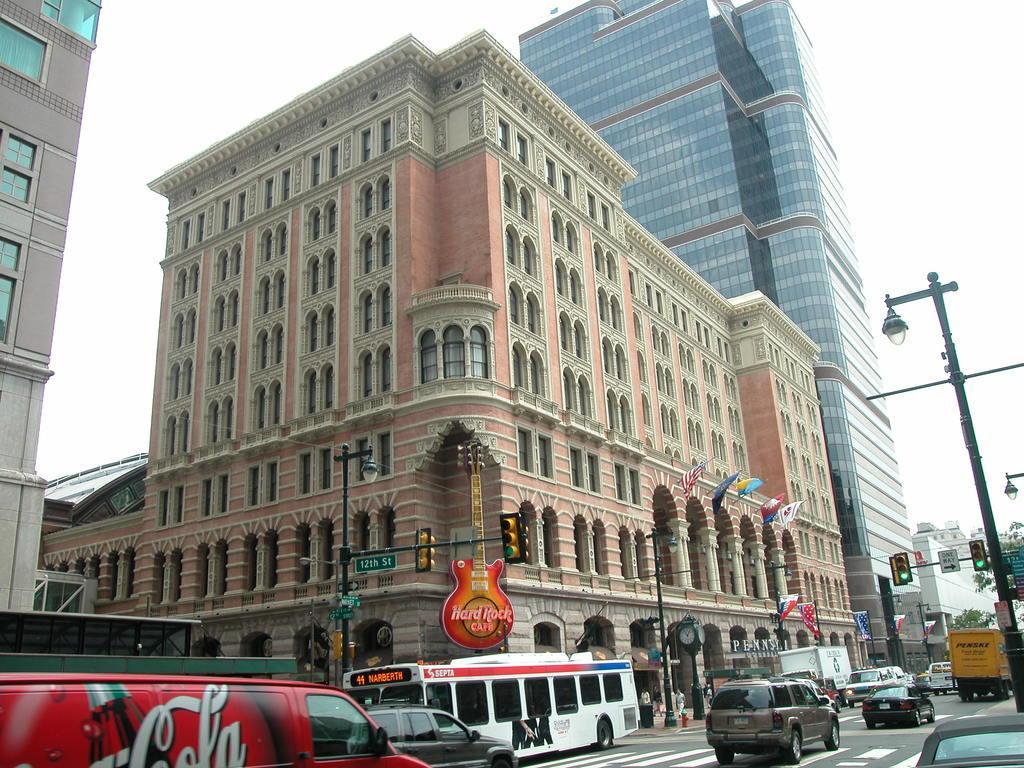In one or two sentences, can you explain what this image depicts? In this image, we can see vehicles on the road and in the background, there are buildings, poles, boards, flags, traffic lights, trees and some people. At the top, there is sky. 